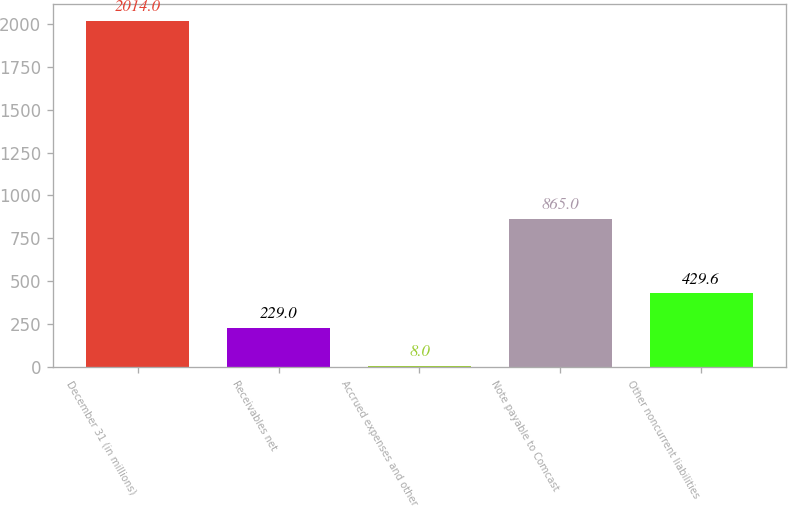Convert chart. <chart><loc_0><loc_0><loc_500><loc_500><bar_chart><fcel>December 31 (in millions)<fcel>Receivables net<fcel>Accrued expenses and other<fcel>Note payable to Comcast<fcel>Other noncurrent liabilities<nl><fcel>2014<fcel>229<fcel>8<fcel>865<fcel>429.6<nl></chart> 